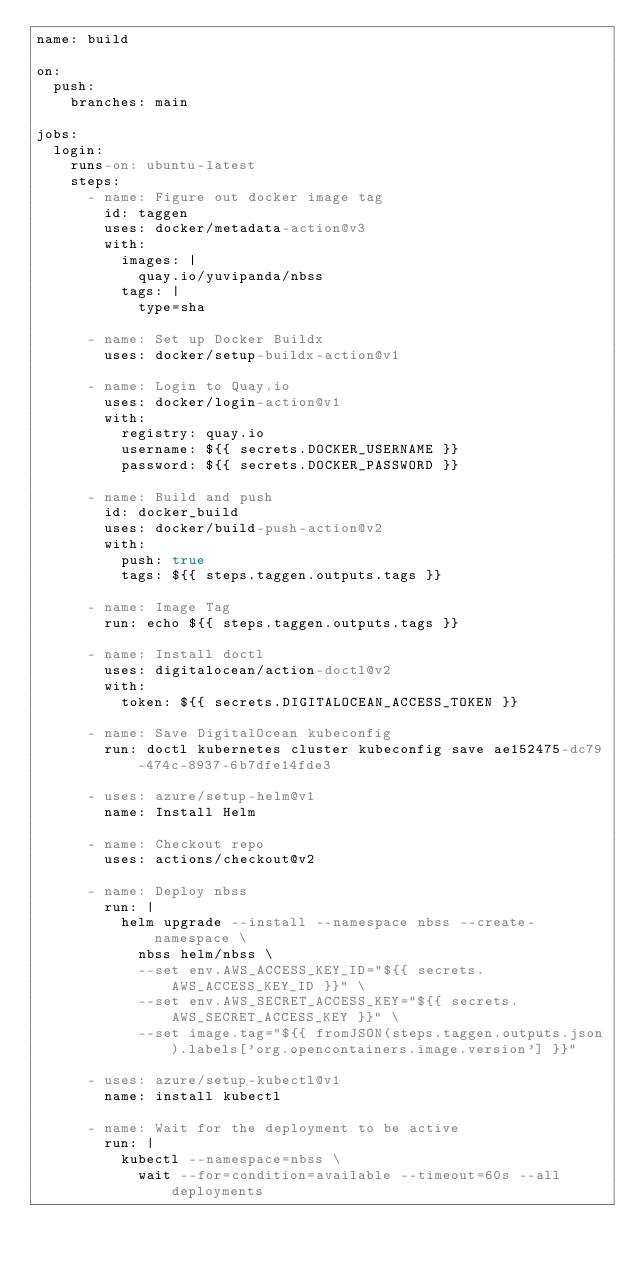<code> <loc_0><loc_0><loc_500><loc_500><_YAML_>name: build

on:
  push:
    branches: main

jobs:
  login:
    runs-on: ubuntu-latest
    steps:
      - name: Figure out docker image tag
        id: taggen
        uses: docker/metadata-action@v3
        with:
          images: |
            quay.io/yuvipanda/nbss
          tags: |
            type=sha

      - name: Set up Docker Buildx
        uses: docker/setup-buildx-action@v1

      - name: Login to Quay.io
        uses: docker/login-action@v1
        with:
          registry: quay.io
          username: ${{ secrets.DOCKER_USERNAME }}
          password: ${{ secrets.DOCKER_PASSWORD }}

      - name: Build and push
        id: docker_build
        uses: docker/build-push-action@v2
        with:
          push: true
          tags: ${{ steps.taggen.outputs.tags }}

      - name: Image Tag
        run: echo ${{ steps.taggen.outputs.tags }}

      - name: Install doctl
        uses: digitalocean/action-doctl@v2
        with:
          token: ${{ secrets.DIGITALOCEAN_ACCESS_TOKEN }}

      - name: Save DigitalOcean kubeconfig
        run: doctl kubernetes cluster kubeconfig save ae152475-dc79-474c-8937-6b7dfe14fde3

      - uses: azure/setup-helm@v1
        name: Install Helm

      - name: Checkout repo
        uses: actions/checkout@v2

      - name: Deploy nbss
        run: |
          helm upgrade --install --namespace nbss --create-namespace \
            nbss helm/nbss \
            --set env.AWS_ACCESS_KEY_ID="${{ secrets.AWS_ACCESS_KEY_ID }}" \
            --set env.AWS_SECRET_ACCESS_KEY="${{ secrets.AWS_SECRET_ACCESS_KEY }}" \
            --set image.tag="${{ fromJSON(steps.taggen.outputs.json).labels['org.opencontainers.image.version'] }}"

      - uses: azure/setup-kubectl@v1
        name: install kubectl

      - name: Wait for the deployment to be active
        run: |
          kubectl --namespace=nbss \
            wait --for=condition=available --timeout=60s --all deployments</code> 